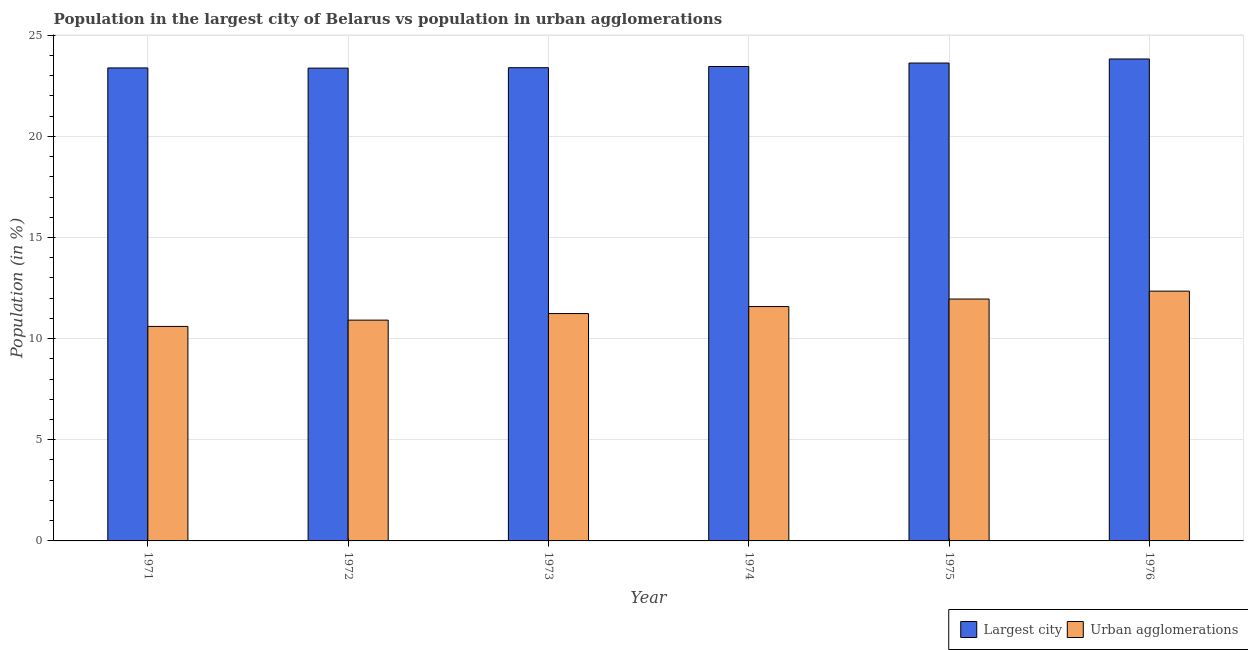How many bars are there on the 2nd tick from the left?
Provide a short and direct response. 2. How many bars are there on the 4th tick from the right?
Offer a very short reply. 2. What is the label of the 6th group of bars from the left?
Make the answer very short. 1976. In how many cases, is the number of bars for a given year not equal to the number of legend labels?
Give a very brief answer. 0. What is the population in urban agglomerations in 1975?
Keep it short and to the point. 11.96. Across all years, what is the maximum population in urban agglomerations?
Offer a terse response. 12.35. Across all years, what is the minimum population in urban agglomerations?
Offer a terse response. 10.6. In which year was the population in urban agglomerations maximum?
Your answer should be compact. 1976. In which year was the population in the largest city minimum?
Offer a terse response. 1972. What is the total population in urban agglomerations in the graph?
Your answer should be compact. 68.64. What is the difference between the population in urban agglomerations in 1971 and that in 1976?
Your answer should be compact. -1.74. What is the difference between the population in urban agglomerations in 1974 and the population in the largest city in 1975?
Your answer should be very brief. -0.37. What is the average population in the largest city per year?
Your answer should be very brief. 23.51. In how many years, is the population in the largest city greater than 24 %?
Provide a short and direct response. 0. What is the ratio of the population in urban agglomerations in 1973 to that in 1976?
Ensure brevity in your answer.  0.91. Is the population in urban agglomerations in 1974 less than that in 1975?
Offer a terse response. Yes. Is the difference between the population in the largest city in 1972 and 1976 greater than the difference between the population in urban agglomerations in 1972 and 1976?
Your response must be concise. No. What is the difference between the highest and the second highest population in the largest city?
Give a very brief answer. 0.2. What is the difference between the highest and the lowest population in urban agglomerations?
Provide a succinct answer. 1.74. In how many years, is the population in urban agglomerations greater than the average population in urban agglomerations taken over all years?
Give a very brief answer. 3. What does the 1st bar from the left in 1975 represents?
Provide a succinct answer. Largest city. What does the 2nd bar from the right in 1974 represents?
Your answer should be compact. Largest city. How many bars are there?
Offer a very short reply. 12. Are all the bars in the graph horizontal?
Make the answer very short. No. How many years are there in the graph?
Offer a very short reply. 6. What is the difference between two consecutive major ticks on the Y-axis?
Your answer should be very brief. 5. Are the values on the major ticks of Y-axis written in scientific E-notation?
Provide a succinct answer. No. Does the graph contain any zero values?
Keep it short and to the point. No. Does the graph contain grids?
Offer a terse response. Yes. Where does the legend appear in the graph?
Give a very brief answer. Bottom right. How many legend labels are there?
Offer a very short reply. 2. How are the legend labels stacked?
Keep it short and to the point. Horizontal. What is the title of the graph?
Give a very brief answer. Population in the largest city of Belarus vs population in urban agglomerations. What is the label or title of the X-axis?
Ensure brevity in your answer.  Year. What is the label or title of the Y-axis?
Offer a terse response. Population (in %). What is the Population (in %) of Largest city in 1971?
Your answer should be very brief. 23.38. What is the Population (in %) in Urban agglomerations in 1971?
Offer a very short reply. 10.6. What is the Population (in %) in Largest city in 1972?
Your answer should be very brief. 23.37. What is the Population (in %) of Urban agglomerations in 1972?
Your answer should be compact. 10.91. What is the Population (in %) in Largest city in 1973?
Your answer should be compact. 23.39. What is the Population (in %) in Urban agglomerations in 1973?
Ensure brevity in your answer.  11.24. What is the Population (in %) of Largest city in 1974?
Ensure brevity in your answer.  23.45. What is the Population (in %) in Urban agglomerations in 1974?
Offer a terse response. 11.58. What is the Population (in %) in Largest city in 1975?
Provide a succinct answer. 23.62. What is the Population (in %) of Urban agglomerations in 1975?
Provide a succinct answer. 11.96. What is the Population (in %) of Largest city in 1976?
Offer a terse response. 23.82. What is the Population (in %) of Urban agglomerations in 1976?
Offer a terse response. 12.35. Across all years, what is the maximum Population (in %) in Largest city?
Your answer should be very brief. 23.82. Across all years, what is the maximum Population (in %) in Urban agglomerations?
Offer a terse response. 12.35. Across all years, what is the minimum Population (in %) of Largest city?
Your answer should be compact. 23.37. Across all years, what is the minimum Population (in %) in Urban agglomerations?
Offer a very short reply. 10.6. What is the total Population (in %) of Largest city in the graph?
Your answer should be very brief. 141.04. What is the total Population (in %) of Urban agglomerations in the graph?
Your answer should be compact. 68.64. What is the difference between the Population (in %) in Urban agglomerations in 1971 and that in 1972?
Keep it short and to the point. -0.31. What is the difference between the Population (in %) in Largest city in 1971 and that in 1973?
Make the answer very short. -0.01. What is the difference between the Population (in %) of Urban agglomerations in 1971 and that in 1973?
Keep it short and to the point. -0.64. What is the difference between the Population (in %) of Largest city in 1971 and that in 1974?
Your response must be concise. -0.07. What is the difference between the Population (in %) in Urban agglomerations in 1971 and that in 1974?
Make the answer very short. -0.98. What is the difference between the Population (in %) of Largest city in 1971 and that in 1975?
Your response must be concise. -0.24. What is the difference between the Population (in %) of Urban agglomerations in 1971 and that in 1975?
Offer a terse response. -1.35. What is the difference between the Population (in %) of Largest city in 1971 and that in 1976?
Make the answer very short. -0.44. What is the difference between the Population (in %) of Urban agglomerations in 1971 and that in 1976?
Offer a terse response. -1.74. What is the difference between the Population (in %) in Largest city in 1972 and that in 1973?
Ensure brevity in your answer.  -0.02. What is the difference between the Population (in %) of Urban agglomerations in 1972 and that in 1973?
Provide a succinct answer. -0.33. What is the difference between the Population (in %) of Largest city in 1972 and that in 1974?
Your response must be concise. -0.08. What is the difference between the Population (in %) in Urban agglomerations in 1972 and that in 1974?
Your answer should be compact. -0.67. What is the difference between the Population (in %) in Largest city in 1972 and that in 1975?
Provide a succinct answer. -0.25. What is the difference between the Population (in %) of Urban agglomerations in 1972 and that in 1975?
Offer a terse response. -1.04. What is the difference between the Population (in %) of Largest city in 1972 and that in 1976?
Provide a short and direct response. -0.45. What is the difference between the Population (in %) of Urban agglomerations in 1972 and that in 1976?
Ensure brevity in your answer.  -1.43. What is the difference between the Population (in %) of Largest city in 1973 and that in 1974?
Make the answer very short. -0.06. What is the difference between the Population (in %) in Urban agglomerations in 1973 and that in 1974?
Provide a short and direct response. -0.35. What is the difference between the Population (in %) of Largest city in 1973 and that in 1975?
Ensure brevity in your answer.  -0.23. What is the difference between the Population (in %) of Urban agglomerations in 1973 and that in 1975?
Ensure brevity in your answer.  -0.72. What is the difference between the Population (in %) in Largest city in 1973 and that in 1976?
Give a very brief answer. -0.43. What is the difference between the Population (in %) in Urban agglomerations in 1973 and that in 1976?
Your answer should be compact. -1.11. What is the difference between the Population (in %) of Largest city in 1974 and that in 1975?
Offer a terse response. -0.17. What is the difference between the Population (in %) of Urban agglomerations in 1974 and that in 1975?
Ensure brevity in your answer.  -0.37. What is the difference between the Population (in %) of Largest city in 1974 and that in 1976?
Give a very brief answer. -0.37. What is the difference between the Population (in %) of Urban agglomerations in 1974 and that in 1976?
Your answer should be very brief. -0.76. What is the difference between the Population (in %) in Largest city in 1975 and that in 1976?
Make the answer very short. -0.2. What is the difference between the Population (in %) in Urban agglomerations in 1975 and that in 1976?
Provide a short and direct response. -0.39. What is the difference between the Population (in %) in Largest city in 1971 and the Population (in %) in Urban agglomerations in 1972?
Your answer should be compact. 12.47. What is the difference between the Population (in %) in Largest city in 1971 and the Population (in %) in Urban agglomerations in 1973?
Give a very brief answer. 12.14. What is the difference between the Population (in %) in Largest city in 1971 and the Population (in %) in Urban agglomerations in 1974?
Make the answer very short. 11.8. What is the difference between the Population (in %) of Largest city in 1971 and the Population (in %) of Urban agglomerations in 1975?
Make the answer very short. 11.42. What is the difference between the Population (in %) of Largest city in 1971 and the Population (in %) of Urban agglomerations in 1976?
Make the answer very short. 11.03. What is the difference between the Population (in %) of Largest city in 1972 and the Population (in %) of Urban agglomerations in 1973?
Your response must be concise. 12.13. What is the difference between the Population (in %) of Largest city in 1972 and the Population (in %) of Urban agglomerations in 1974?
Give a very brief answer. 11.79. What is the difference between the Population (in %) of Largest city in 1972 and the Population (in %) of Urban agglomerations in 1975?
Offer a very short reply. 11.41. What is the difference between the Population (in %) of Largest city in 1972 and the Population (in %) of Urban agglomerations in 1976?
Give a very brief answer. 11.02. What is the difference between the Population (in %) in Largest city in 1973 and the Population (in %) in Urban agglomerations in 1974?
Provide a succinct answer. 11.81. What is the difference between the Population (in %) of Largest city in 1973 and the Population (in %) of Urban agglomerations in 1975?
Give a very brief answer. 11.44. What is the difference between the Population (in %) in Largest city in 1973 and the Population (in %) in Urban agglomerations in 1976?
Ensure brevity in your answer.  11.04. What is the difference between the Population (in %) in Largest city in 1974 and the Population (in %) in Urban agglomerations in 1975?
Your answer should be very brief. 11.49. What is the difference between the Population (in %) in Largest city in 1974 and the Population (in %) in Urban agglomerations in 1976?
Your answer should be compact. 11.1. What is the difference between the Population (in %) of Largest city in 1975 and the Population (in %) of Urban agglomerations in 1976?
Provide a succinct answer. 11.27. What is the average Population (in %) of Largest city per year?
Make the answer very short. 23.51. What is the average Population (in %) in Urban agglomerations per year?
Provide a succinct answer. 11.44. In the year 1971, what is the difference between the Population (in %) of Largest city and Population (in %) of Urban agglomerations?
Your response must be concise. 12.78. In the year 1972, what is the difference between the Population (in %) in Largest city and Population (in %) in Urban agglomerations?
Provide a succinct answer. 12.46. In the year 1973, what is the difference between the Population (in %) in Largest city and Population (in %) in Urban agglomerations?
Provide a short and direct response. 12.15. In the year 1974, what is the difference between the Population (in %) in Largest city and Population (in %) in Urban agglomerations?
Ensure brevity in your answer.  11.87. In the year 1975, what is the difference between the Population (in %) of Largest city and Population (in %) of Urban agglomerations?
Provide a succinct answer. 11.67. In the year 1976, what is the difference between the Population (in %) of Largest city and Population (in %) of Urban agglomerations?
Make the answer very short. 11.48. What is the ratio of the Population (in %) in Urban agglomerations in 1971 to that in 1972?
Give a very brief answer. 0.97. What is the ratio of the Population (in %) in Urban agglomerations in 1971 to that in 1973?
Offer a terse response. 0.94. What is the ratio of the Population (in %) in Largest city in 1971 to that in 1974?
Provide a succinct answer. 1. What is the ratio of the Population (in %) in Urban agglomerations in 1971 to that in 1974?
Give a very brief answer. 0.92. What is the ratio of the Population (in %) of Largest city in 1971 to that in 1975?
Ensure brevity in your answer.  0.99. What is the ratio of the Population (in %) in Urban agglomerations in 1971 to that in 1975?
Keep it short and to the point. 0.89. What is the ratio of the Population (in %) in Largest city in 1971 to that in 1976?
Give a very brief answer. 0.98. What is the ratio of the Population (in %) in Urban agglomerations in 1971 to that in 1976?
Your response must be concise. 0.86. What is the ratio of the Population (in %) of Largest city in 1972 to that in 1973?
Make the answer very short. 1. What is the ratio of the Population (in %) in Urban agglomerations in 1972 to that in 1973?
Ensure brevity in your answer.  0.97. What is the ratio of the Population (in %) in Largest city in 1972 to that in 1974?
Offer a terse response. 1. What is the ratio of the Population (in %) of Urban agglomerations in 1972 to that in 1974?
Your answer should be very brief. 0.94. What is the ratio of the Population (in %) of Urban agglomerations in 1972 to that in 1975?
Keep it short and to the point. 0.91. What is the ratio of the Population (in %) in Urban agglomerations in 1972 to that in 1976?
Provide a succinct answer. 0.88. What is the ratio of the Population (in %) of Largest city in 1973 to that in 1974?
Give a very brief answer. 1. What is the ratio of the Population (in %) of Urban agglomerations in 1973 to that in 1974?
Offer a terse response. 0.97. What is the ratio of the Population (in %) in Largest city in 1973 to that in 1975?
Ensure brevity in your answer.  0.99. What is the ratio of the Population (in %) of Urban agglomerations in 1973 to that in 1975?
Keep it short and to the point. 0.94. What is the ratio of the Population (in %) of Largest city in 1973 to that in 1976?
Your answer should be very brief. 0.98. What is the ratio of the Population (in %) of Urban agglomerations in 1973 to that in 1976?
Your answer should be compact. 0.91. What is the ratio of the Population (in %) in Urban agglomerations in 1974 to that in 1975?
Provide a short and direct response. 0.97. What is the ratio of the Population (in %) of Largest city in 1974 to that in 1976?
Keep it short and to the point. 0.98. What is the ratio of the Population (in %) of Urban agglomerations in 1974 to that in 1976?
Make the answer very short. 0.94. What is the ratio of the Population (in %) in Urban agglomerations in 1975 to that in 1976?
Keep it short and to the point. 0.97. What is the difference between the highest and the second highest Population (in %) of Largest city?
Keep it short and to the point. 0.2. What is the difference between the highest and the second highest Population (in %) of Urban agglomerations?
Provide a succinct answer. 0.39. What is the difference between the highest and the lowest Population (in %) of Largest city?
Offer a terse response. 0.45. What is the difference between the highest and the lowest Population (in %) in Urban agglomerations?
Your answer should be very brief. 1.74. 